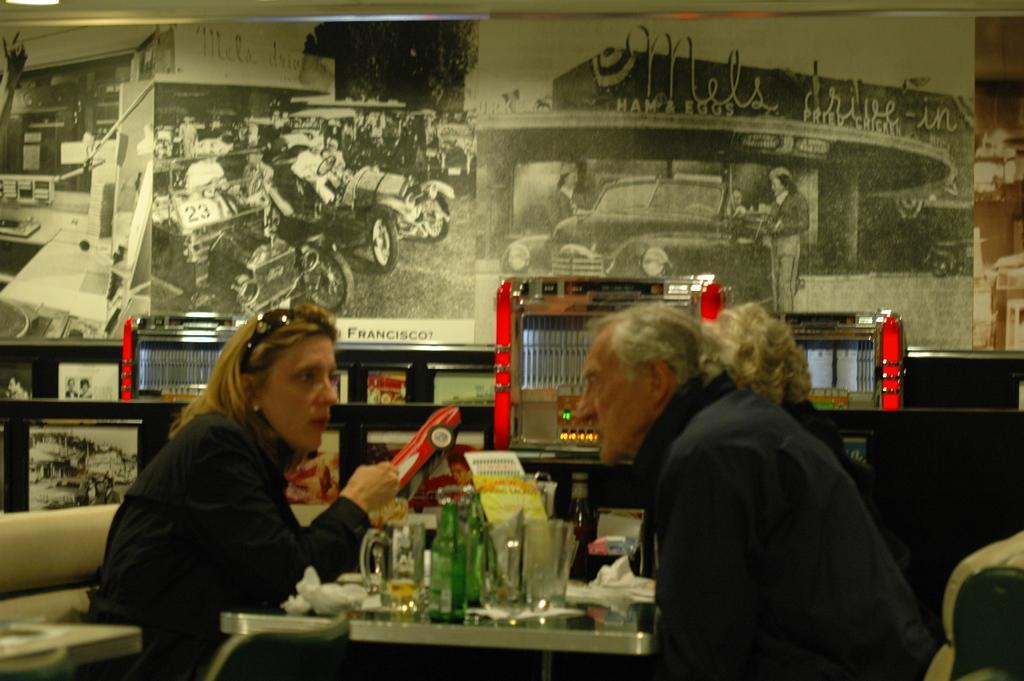How would you summarize this image in a sentence or two? In this image we can see three persons. In the middle we can see group of objects on the surface. Behind the persons we can see few objects and posters. On the posters we can see few vehicles and persons. 